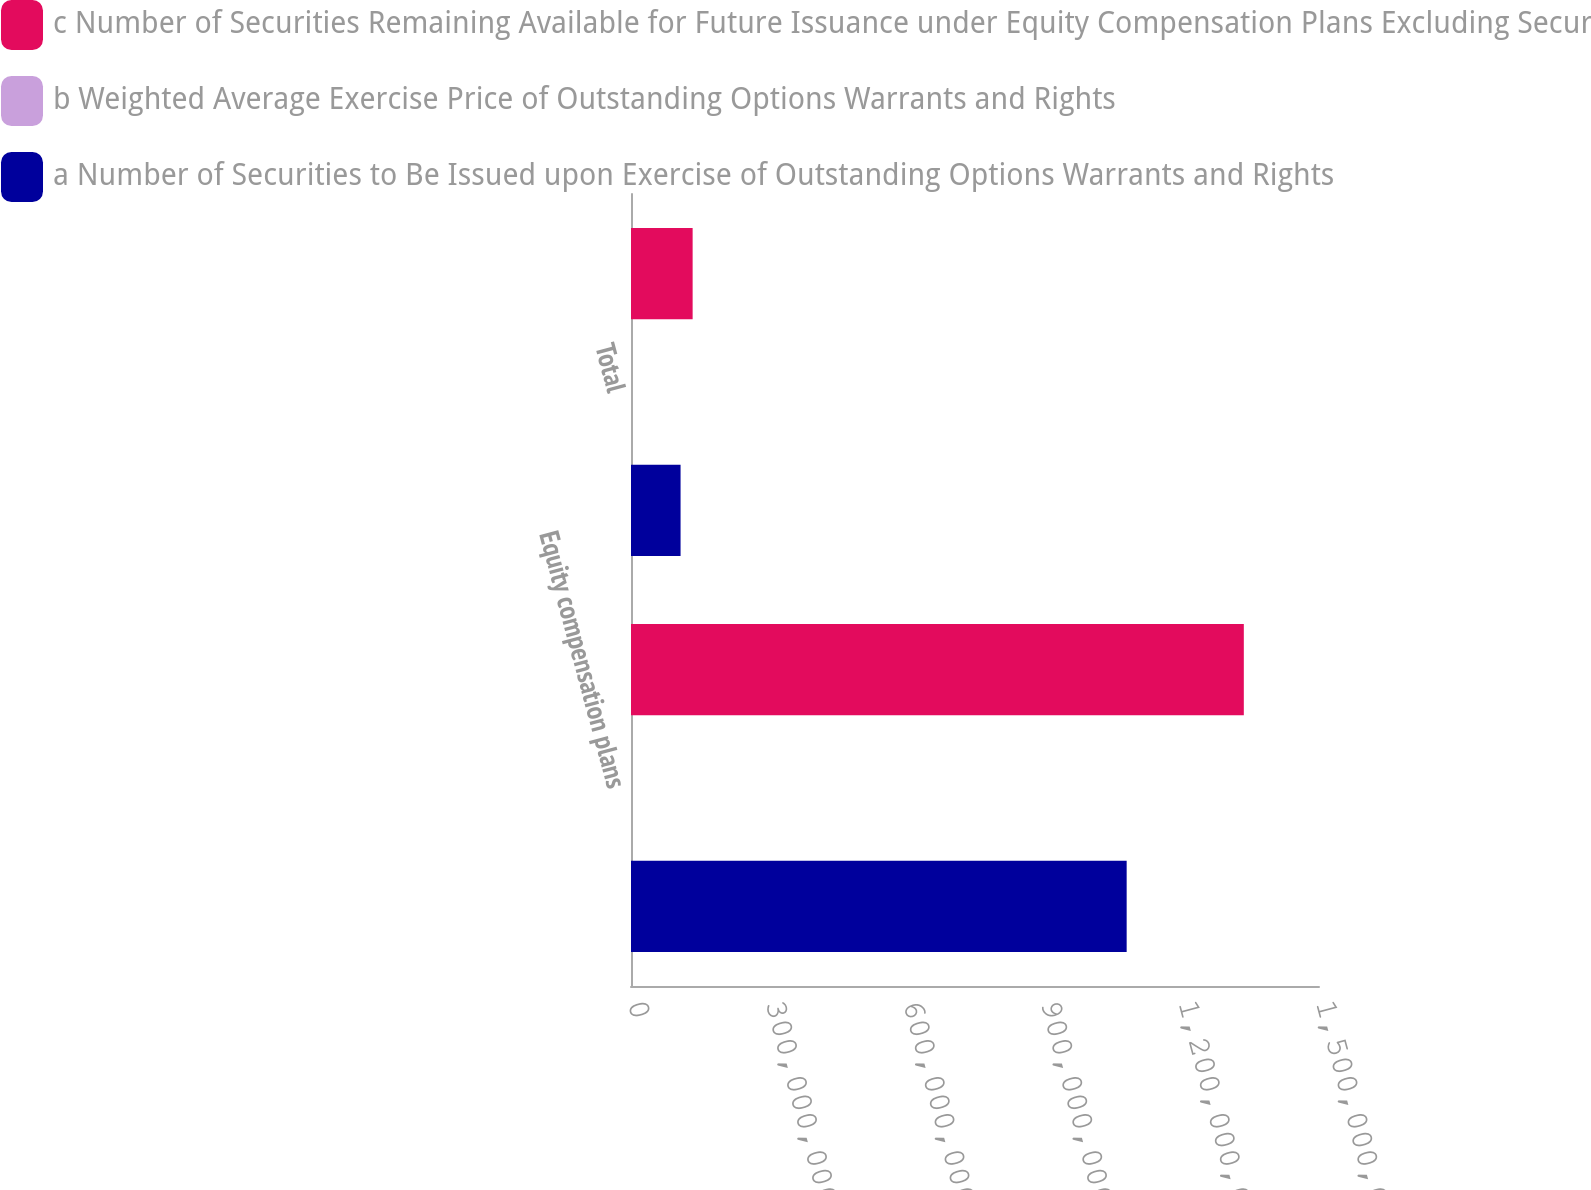<chart> <loc_0><loc_0><loc_500><loc_500><stacked_bar_chart><ecel><fcel>Equity compensation plans<fcel>Total<nl><fcel>c Number of Securities Remaining Available for Future Issuance under Equity Compensation Plans Excluding Securities Reflected in Columna<fcel>1.33608e+09<fcel>1.34377e+08<nl><fcel>b Weighted Average Exercise Price of Outstanding Options Warrants and Rights<fcel>31.01<fcel>30.83<nl><fcel>a Number of Securities to Be Issued upon Exercise of Outstanding Options Warrants and Rights<fcel>1.08067e+09<fcel>1.08067e+08<nl></chart> 